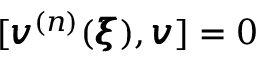<formula> <loc_0><loc_0><loc_500><loc_500>[ { \pm b v } ^ { ( n ) } ( { \pm b \xi } ) , { \pm b v } ] = 0</formula> 